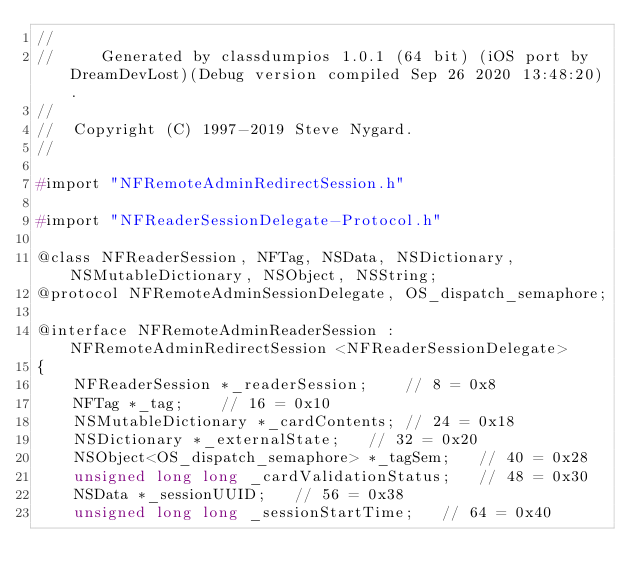<code> <loc_0><loc_0><loc_500><loc_500><_C_>//
//     Generated by classdumpios 1.0.1 (64 bit) (iOS port by DreamDevLost)(Debug version compiled Sep 26 2020 13:48:20).
//
//  Copyright (C) 1997-2019 Steve Nygard.
//

#import "NFRemoteAdminRedirectSession.h"

#import "NFReaderSessionDelegate-Protocol.h"

@class NFReaderSession, NFTag, NSData, NSDictionary, NSMutableDictionary, NSObject, NSString;
@protocol NFRemoteAdminSessionDelegate, OS_dispatch_semaphore;

@interface NFRemoteAdminReaderSession : NFRemoteAdminRedirectSession <NFReaderSessionDelegate>
{
    NFReaderSession *_readerSession;	// 8 = 0x8
    NFTag *_tag;	// 16 = 0x10
    NSMutableDictionary *_cardContents;	// 24 = 0x18
    NSDictionary *_externalState;	// 32 = 0x20
    NSObject<OS_dispatch_semaphore> *_tagSem;	// 40 = 0x28
    unsigned long long _cardValidationStatus;	// 48 = 0x30
    NSData *_sessionUUID;	// 56 = 0x38
    unsigned long long _sessionStartTime;	// 64 = 0x40</code> 